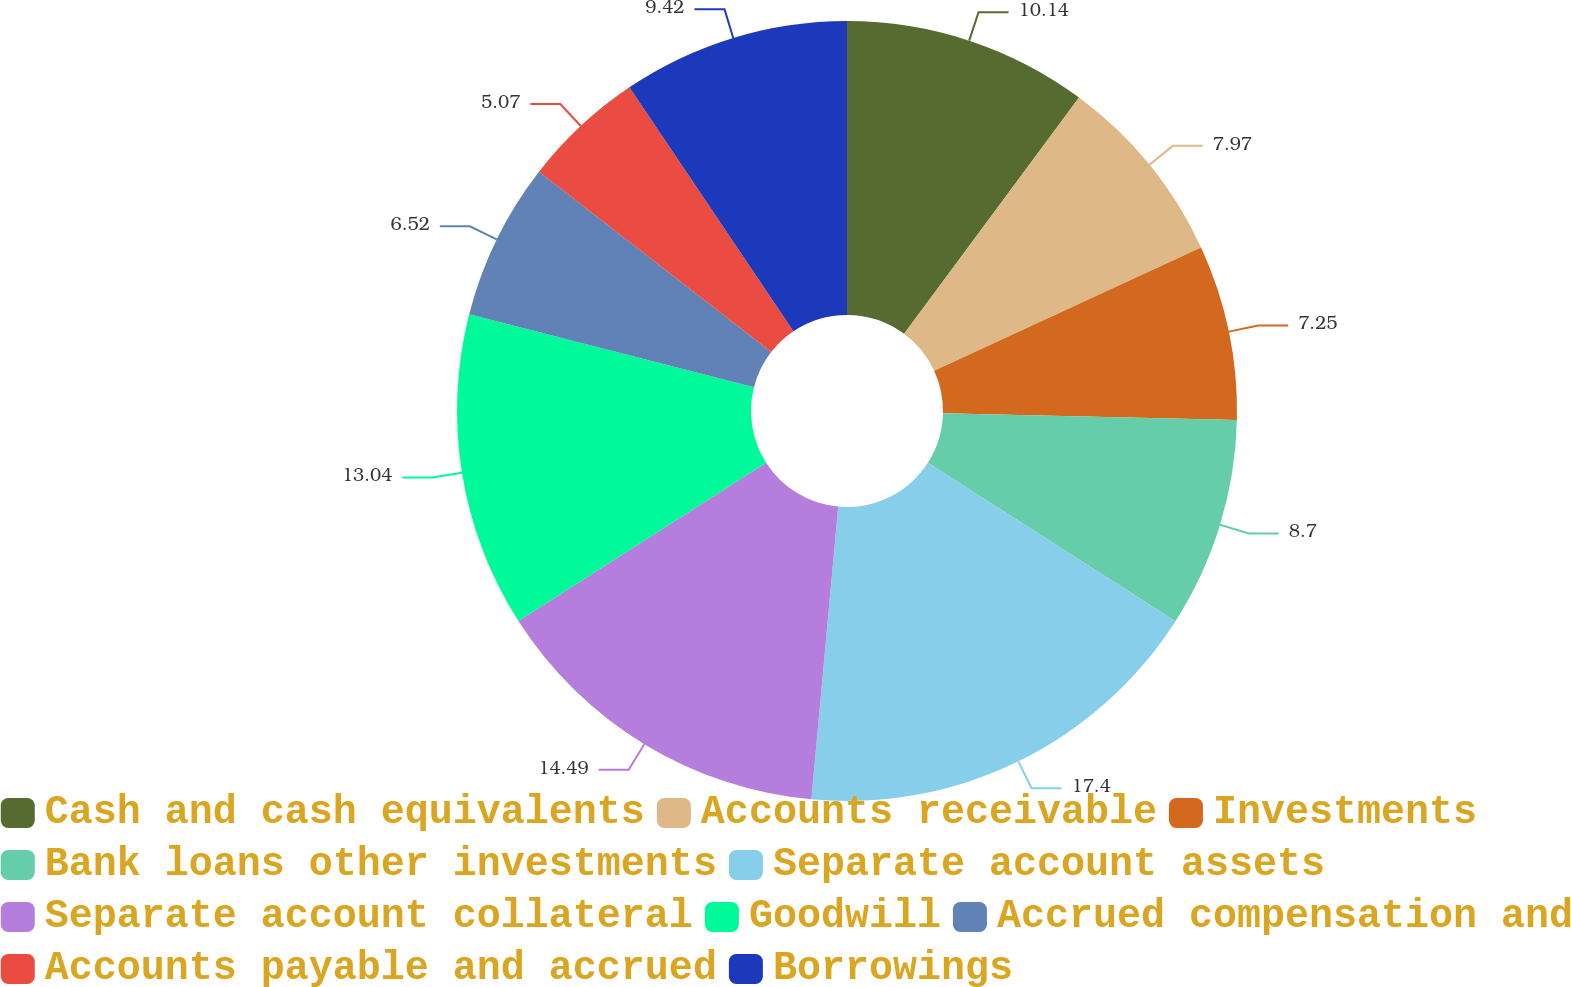<chart> <loc_0><loc_0><loc_500><loc_500><pie_chart><fcel>Cash and cash equivalents<fcel>Accounts receivable<fcel>Investments<fcel>Bank loans other investments<fcel>Separate account assets<fcel>Separate account collateral<fcel>Goodwill<fcel>Accrued compensation and<fcel>Accounts payable and accrued<fcel>Borrowings<nl><fcel>10.14%<fcel>7.97%<fcel>7.25%<fcel>8.7%<fcel>17.39%<fcel>14.49%<fcel>13.04%<fcel>6.52%<fcel>5.07%<fcel>9.42%<nl></chart> 